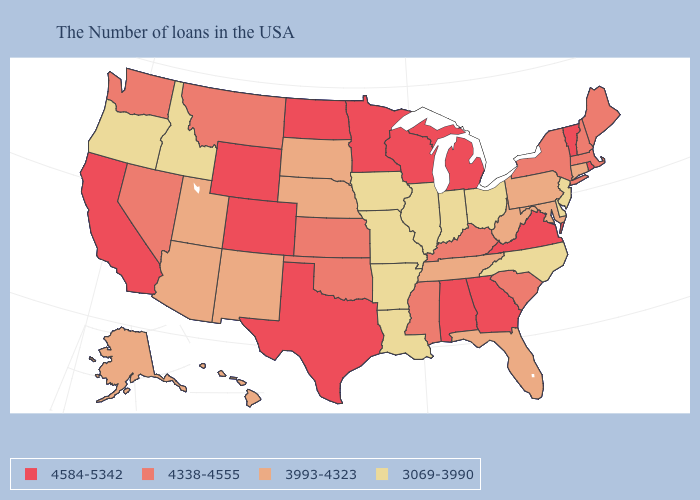Does Missouri have a lower value than Iowa?
Write a very short answer. No. What is the value of Oklahoma?
Give a very brief answer. 4338-4555. Which states have the highest value in the USA?
Quick response, please. Rhode Island, Vermont, Virginia, Georgia, Michigan, Alabama, Wisconsin, Minnesota, Texas, North Dakota, Wyoming, Colorado, California. Is the legend a continuous bar?
Quick response, please. No. Among the states that border Minnesota , which have the lowest value?
Be succinct. Iowa. Does the first symbol in the legend represent the smallest category?
Give a very brief answer. No. Name the states that have a value in the range 4584-5342?
Concise answer only. Rhode Island, Vermont, Virginia, Georgia, Michigan, Alabama, Wisconsin, Minnesota, Texas, North Dakota, Wyoming, Colorado, California. Does Wyoming have the highest value in the West?
Give a very brief answer. Yes. Does Kentucky have the highest value in the South?
Concise answer only. No. Among the states that border Vermont , which have the highest value?
Keep it brief. Massachusetts, New Hampshire, New York. Among the states that border North Dakota , does South Dakota have the lowest value?
Answer briefly. Yes. Which states have the highest value in the USA?
Short answer required. Rhode Island, Vermont, Virginia, Georgia, Michigan, Alabama, Wisconsin, Minnesota, Texas, North Dakota, Wyoming, Colorado, California. What is the highest value in the MidWest ?
Write a very short answer. 4584-5342. What is the value of Texas?
Short answer required. 4584-5342. 